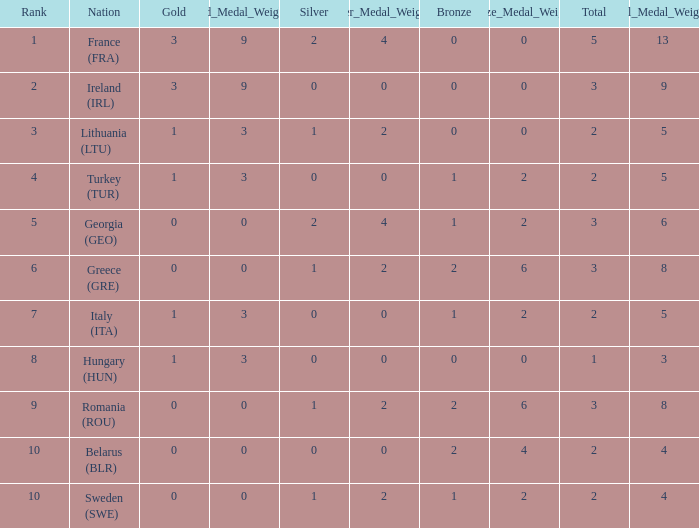What's the total number of bronze medals for Sweden (SWE) having less than 1 gold and silver? 0.0. 